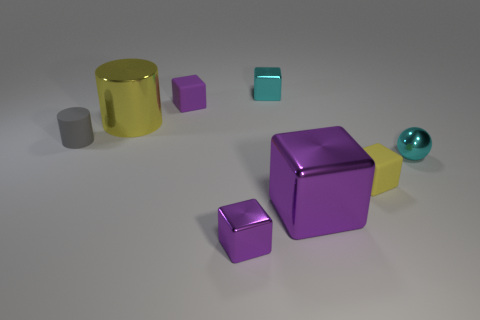There is a cyan metallic sphere; is it the same size as the purple object that is behind the gray thing?
Make the answer very short. Yes. What is the material of the purple block behind the big cube?
Provide a short and direct response. Rubber. Is the number of gray matte things that are to the left of the yellow matte thing the same as the number of blue metal blocks?
Your response must be concise. No. Do the gray cylinder and the yellow matte block have the same size?
Your response must be concise. Yes. There is a object that is in front of the big object that is in front of the tiny matte cylinder; are there any tiny objects that are in front of it?
Provide a short and direct response. No. What material is the yellow thing that is the same shape as the big purple metal object?
Ensure brevity in your answer.  Rubber. How many large cylinders are behind the cyan metallic object that is in front of the yellow metallic cylinder?
Give a very brief answer. 1. What size is the matte block that is behind the rubber thing that is on the right side of the small cyan metal object behind the tiny sphere?
Your answer should be very brief. Small. There is a metallic block to the right of the cyan object that is behind the big yellow shiny object; what is its color?
Provide a short and direct response. Purple. What number of other things are the same material as the cyan cube?
Your answer should be compact. 4. 